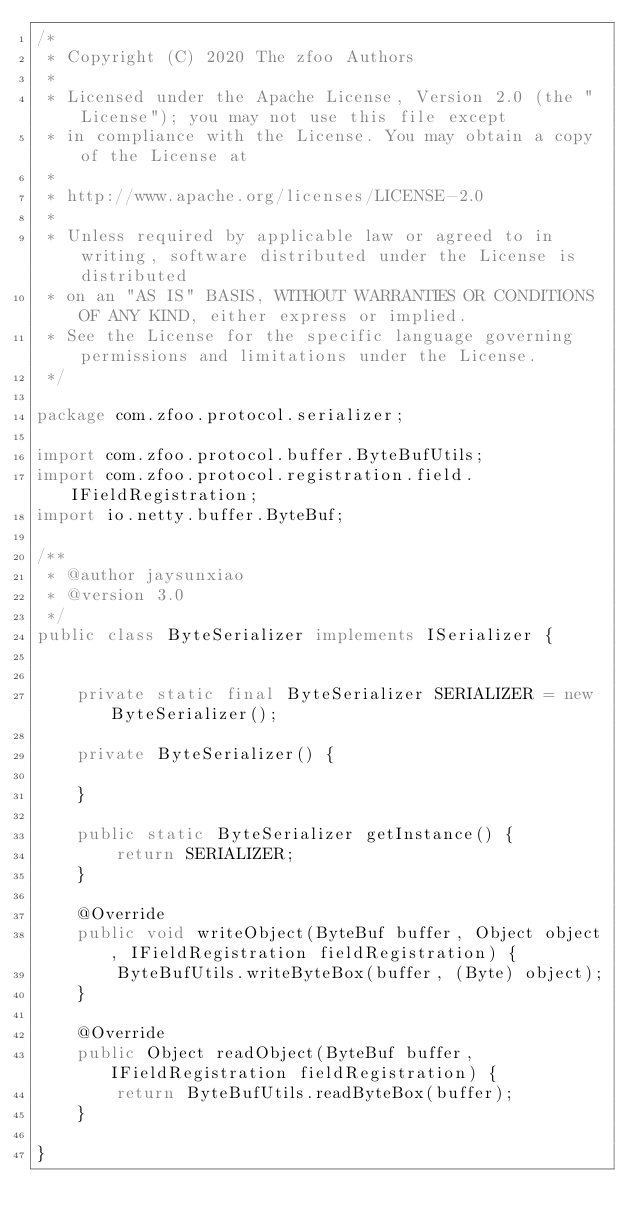<code> <loc_0><loc_0><loc_500><loc_500><_Java_>/*
 * Copyright (C) 2020 The zfoo Authors
 *
 * Licensed under the Apache License, Version 2.0 (the "License"); you may not use this file except
 * in compliance with the License. You may obtain a copy of the License at
 *
 * http://www.apache.org/licenses/LICENSE-2.0
 *
 * Unless required by applicable law or agreed to in writing, software distributed under the License is distributed
 * on an "AS IS" BASIS, WITHOUT WARRANTIES OR CONDITIONS OF ANY KIND, either express or implied.
 * See the License for the specific language governing permissions and limitations under the License.
 */

package com.zfoo.protocol.serializer;

import com.zfoo.protocol.buffer.ByteBufUtils;
import com.zfoo.protocol.registration.field.IFieldRegistration;
import io.netty.buffer.ByteBuf;

/**
 * @author jaysunxiao
 * @version 3.0
 */
public class ByteSerializer implements ISerializer {


    private static final ByteSerializer SERIALIZER = new ByteSerializer();

    private ByteSerializer() {

    }

    public static ByteSerializer getInstance() {
        return SERIALIZER;
    }

    @Override
    public void writeObject(ByteBuf buffer, Object object, IFieldRegistration fieldRegistration) {
        ByteBufUtils.writeByteBox(buffer, (Byte) object);
    }

    @Override
    public Object readObject(ByteBuf buffer, IFieldRegistration fieldRegistration) {
        return ByteBufUtils.readByteBox(buffer);
    }

}
</code> 